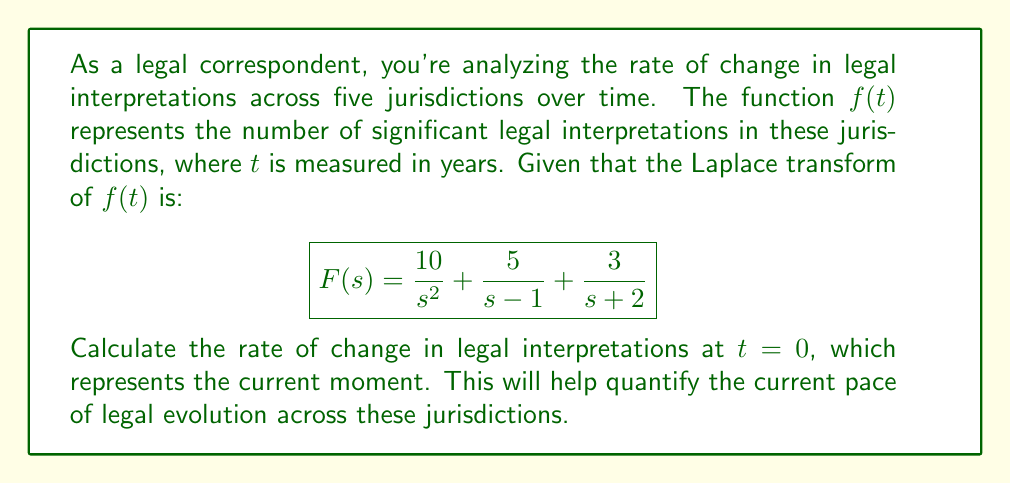What is the answer to this math problem? To solve this problem, we'll follow these steps:

1) The rate of change in legal interpretations is represented by the first derivative of $f(t)$ at $t = 0$, i.e., $f'(0)$.

2) To find $f'(0)$, we need to first find $f(t)$ by taking the inverse Laplace transform of $F(s)$.

3) Let's break down $F(s)$ into its components:
   $$F(s) = \frac{10}{s^2} + \frac{5}{s-1} + \frac{3}{s+2}$$

4) Taking the inverse Laplace transform of each term:
   - $\mathcal{L}^{-1}\{\frac{10}{s^2}\} = 10t$
   - $\mathcal{L}^{-1}\{\frac{5}{s-1}\} = 5e^t$
   - $\mathcal{L}^{-1}\{\frac{3}{s+2}\} = 3e^{-2t}$

5) Therefore, $f(t) = 10t + 5e^t + 3e^{-2t}$

6) Now, let's find $f'(t)$:
   $f'(t) = 10 + 5e^t - 6e^{-2t}$

7) Evaluating at $t = 0$:
   $f'(0) = 10 + 5e^0 - 6e^0 = 10 + 5 - 6 = 9$

Thus, the rate of change in legal interpretations at the current moment $(t = 0)$ is 9 interpretations per year.
Answer: 9 interpretations/year 